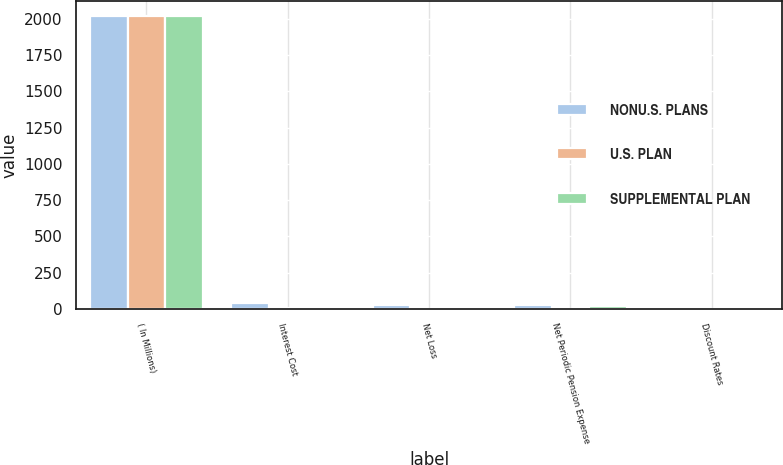Convert chart. <chart><loc_0><loc_0><loc_500><loc_500><stacked_bar_chart><ecel><fcel>( In Millions)<fcel>Interest Cost<fcel>Net Loss<fcel>Net Periodic Pension Expense<fcel>Discount Rates<nl><fcel>NONU.S. PLANS<fcel>2018<fcel>44.3<fcel>28.2<fcel>25.3<fcel>3.79<nl><fcel>U.S. PLAN<fcel>2018<fcel>4<fcel>0.9<fcel>2.9<fcel>2.08<nl><fcel>SUPPLEMENTAL PLAN<fcel>2018<fcel>5.3<fcel>7.4<fcel>17.2<fcel>3.79<nl></chart> 